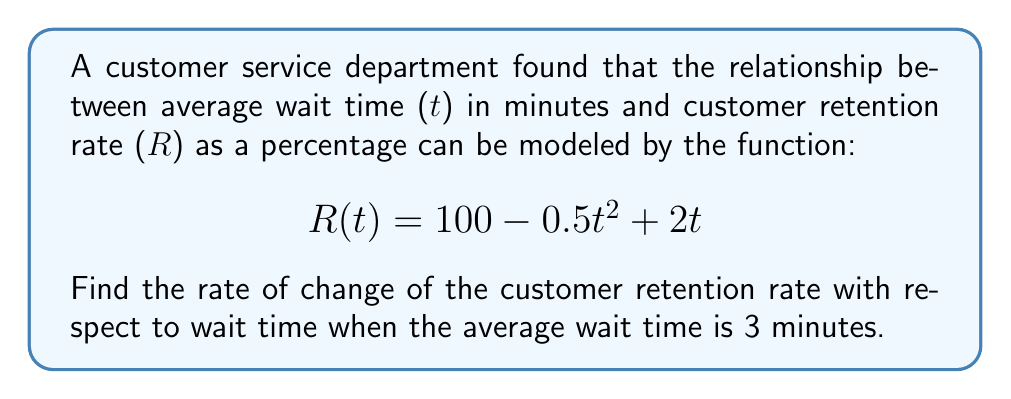Help me with this question. To find the rate of change of the customer retention rate with respect to wait time, we need to find the derivative of the given function R(t).

Step 1: Identify the function
$$R(t) = 100 - 0.5t^2 + 2t$$

Step 2: Calculate the derivative R'(t)
Using the power rule and constant rule of differentiation:
$$R'(t) = 0 - 0.5 \cdot 2t + 2$$
$$R'(t) = -t + 2$$

Step 3: Evaluate R'(t) at t = 3
$$R'(3) = -3 + 2 = -1$$

The negative value indicates that the customer retention rate is decreasing as wait time increases at this point.
Answer: $-1\%$ per minute 